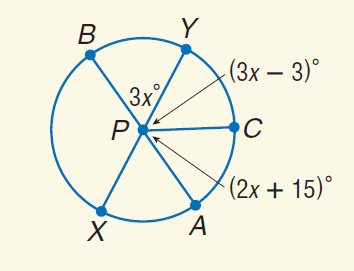Answer the mathemtical geometry problem and directly provide the correct option letter.
Question: Find m \widehat B X.
Choices: A: 21 B: 45 C: 63 D: 117 D 